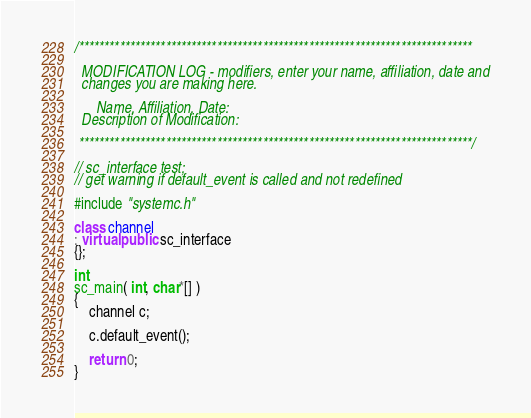<code> <loc_0><loc_0><loc_500><loc_500><_C++_>
/*****************************************************************************

  MODIFICATION LOG - modifiers, enter your name, affiliation, date and
  changes you are making here.

      Name, Affiliation, Date:
  Description of Modification:

 *****************************************************************************/

// sc_interface test;
// get warning if default_event is called and not redefined

#include "systemc.h"

class channel
: virtual public sc_interface
{};

int
sc_main( int, char*[] )
{
    channel c;

    c.default_event();

    return 0;
}
</code> 